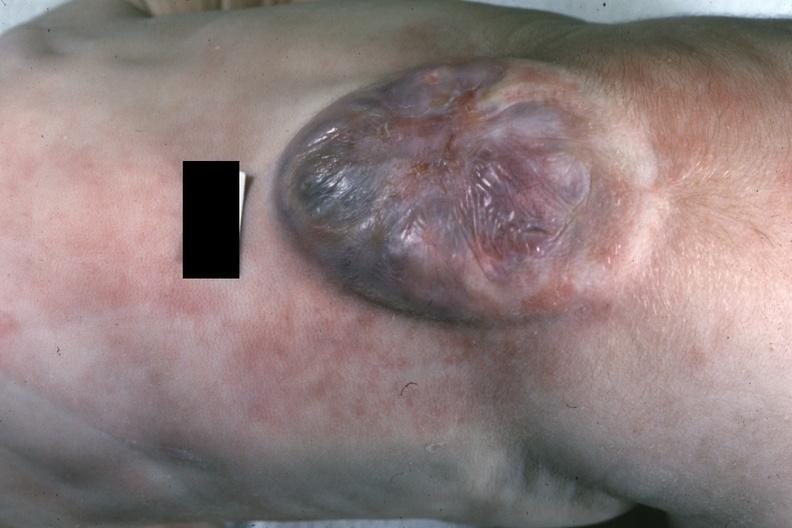s spina bifida present?
Answer the question using a single word or phrase. Yes 